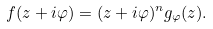Convert formula to latex. <formula><loc_0><loc_0><loc_500><loc_500>f ( z + i \varphi ) = ( z + i \varphi ) ^ { n } g _ { \varphi } ( z ) .</formula> 